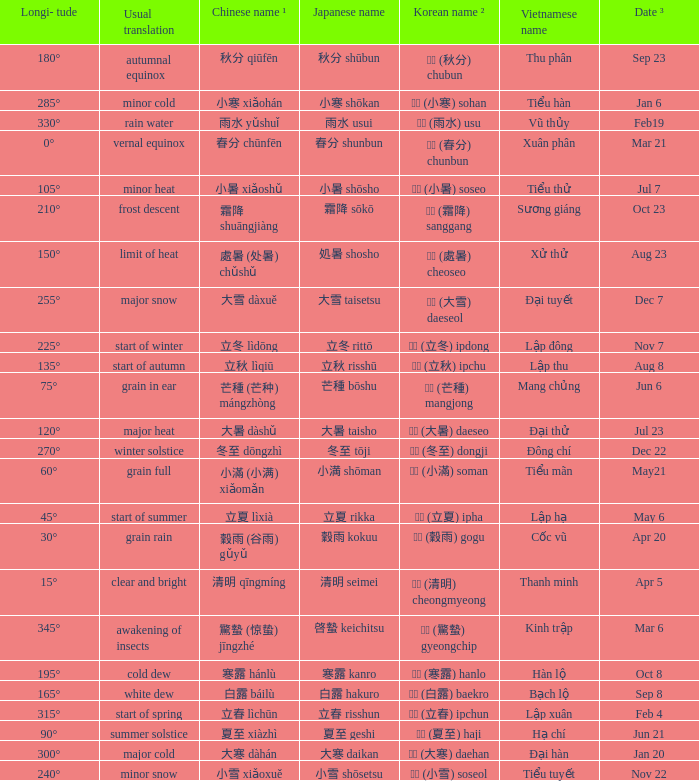Can you parse all the data within this table? {'header': ['Longi- tude', 'Usual translation', 'Chinese name ¹', 'Japanese name', 'Korean name ²', 'Vietnamese name', 'Date ³'], 'rows': [['180°', 'autumnal equinox', '秋分 qiūfēn', '秋分 shūbun', '추분 (秋分) chubun', 'Thu phân', 'Sep 23'], ['285°', 'minor cold', '小寒 xiǎohán', '小寒 shōkan', '소한 (小寒) sohan', 'Tiểu hàn', 'Jan 6'], ['330°', 'rain water', '雨水 yǔshuǐ', '雨水 usui', '우수 (雨水) usu', 'Vũ thủy', 'Feb19'], ['0°', 'vernal equinox', '春分 chūnfēn', '春分 shunbun', '춘분 (春分) chunbun', 'Xuân phân', 'Mar 21'], ['105°', 'minor heat', '小暑 xiǎoshǔ', '小暑 shōsho', '소서 (小暑) soseo', 'Tiểu thử', 'Jul 7'], ['210°', 'frost descent', '霜降 shuāngjiàng', '霜降 sōkō', '상강 (霜降) sanggang', 'Sương giáng', 'Oct 23'], ['150°', 'limit of heat', '處暑 (处暑) chǔshǔ', '処暑 shosho', '처서 (處暑) cheoseo', 'Xử thử', 'Aug 23'], ['255°', 'major snow', '大雪 dàxuě', '大雪 taisetsu', '대설 (大雪) daeseol', 'Đại tuyết', 'Dec 7'], ['225°', 'start of winter', '立冬 lìdōng', '立冬 rittō', '입동 (立冬) ipdong', 'Lập đông', 'Nov 7'], ['135°', 'start of autumn', '立秋 lìqiū', '立秋 risshū', '입추 (立秋) ipchu', 'Lập thu', 'Aug 8'], ['75°', 'grain in ear', '芒種 (芒种) mángzhòng', '芒種 bōshu', '망종 (芒種) mangjong', 'Mang chủng', 'Jun 6'], ['120°', 'major heat', '大暑 dàshǔ', '大暑 taisho', '대서 (大暑) daeseo', 'Đại thử', 'Jul 23'], ['270°', 'winter solstice', '冬至 dōngzhì', '冬至 tōji', '동지 (冬至) dongji', 'Đông chí', 'Dec 22'], ['60°', 'grain full', '小滿 (小满) xiǎomǎn', '小満 shōman', '소만 (小滿) soman', 'Tiểu mãn', 'May21'], ['45°', 'start of summer', '立夏 lìxià', '立夏 rikka', '입하 (立夏) ipha', 'Lập hạ', 'May 6'], ['30°', 'grain rain', '穀雨 (谷雨) gǔyǔ', '穀雨 kokuu', '곡우 (穀雨) gogu', 'Cốc vũ', 'Apr 20'], ['15°', 'clear and bright', '清明 qīngmíng', '清明 seimei', '청명 (清明) cheongmyeong', 'Thanh minh', 'Apr 5'], ['345°', 'awakening of insects', '驚蟄 (惊蛰) jīngzhé', '啓蟄 keichitsu', '경칩 (驚蟄) gyeongchip', 'Kinh trập', 'Mar 6'], ['195°', 'cold dew', '寒露 hánlù', '寒露 kanro', '한로 (寒露) hanlo', 'Hàn lộ', 'Oct 8'], ['165°', 'white dew', '白露 báilù', '白露 hakuro', '백로 (白露) baekro', 'Bạch lộ', 'Sep 8'], ['315°', 'start of spring', '立春 lìchūn', '立春 risshun', '입춘 (立春) ipchun', 'Lập xuân', 'Feb 4'], ['90°', 'summer solstice', '夏至 xiàzhì', '夏至 geshi', '하지 (夏至) haji', 'Hạ chí', 'Jun 21'], ['300°', 'major cold', '大寒 dàhán', '大寒 daikan', '대한 (大寒) daehan', 'Đại hàn', 'Jan 20'], ['240°', 'minor snow', '小雪 xiǎoxuě', '小雪 shōsetsu', '소설 (小雪) soseol', 'Tiểu tuyết', 'Nov 22']]} When has a Korean name ² of 청명 (清明) cheongmyeong? Apr 5. 